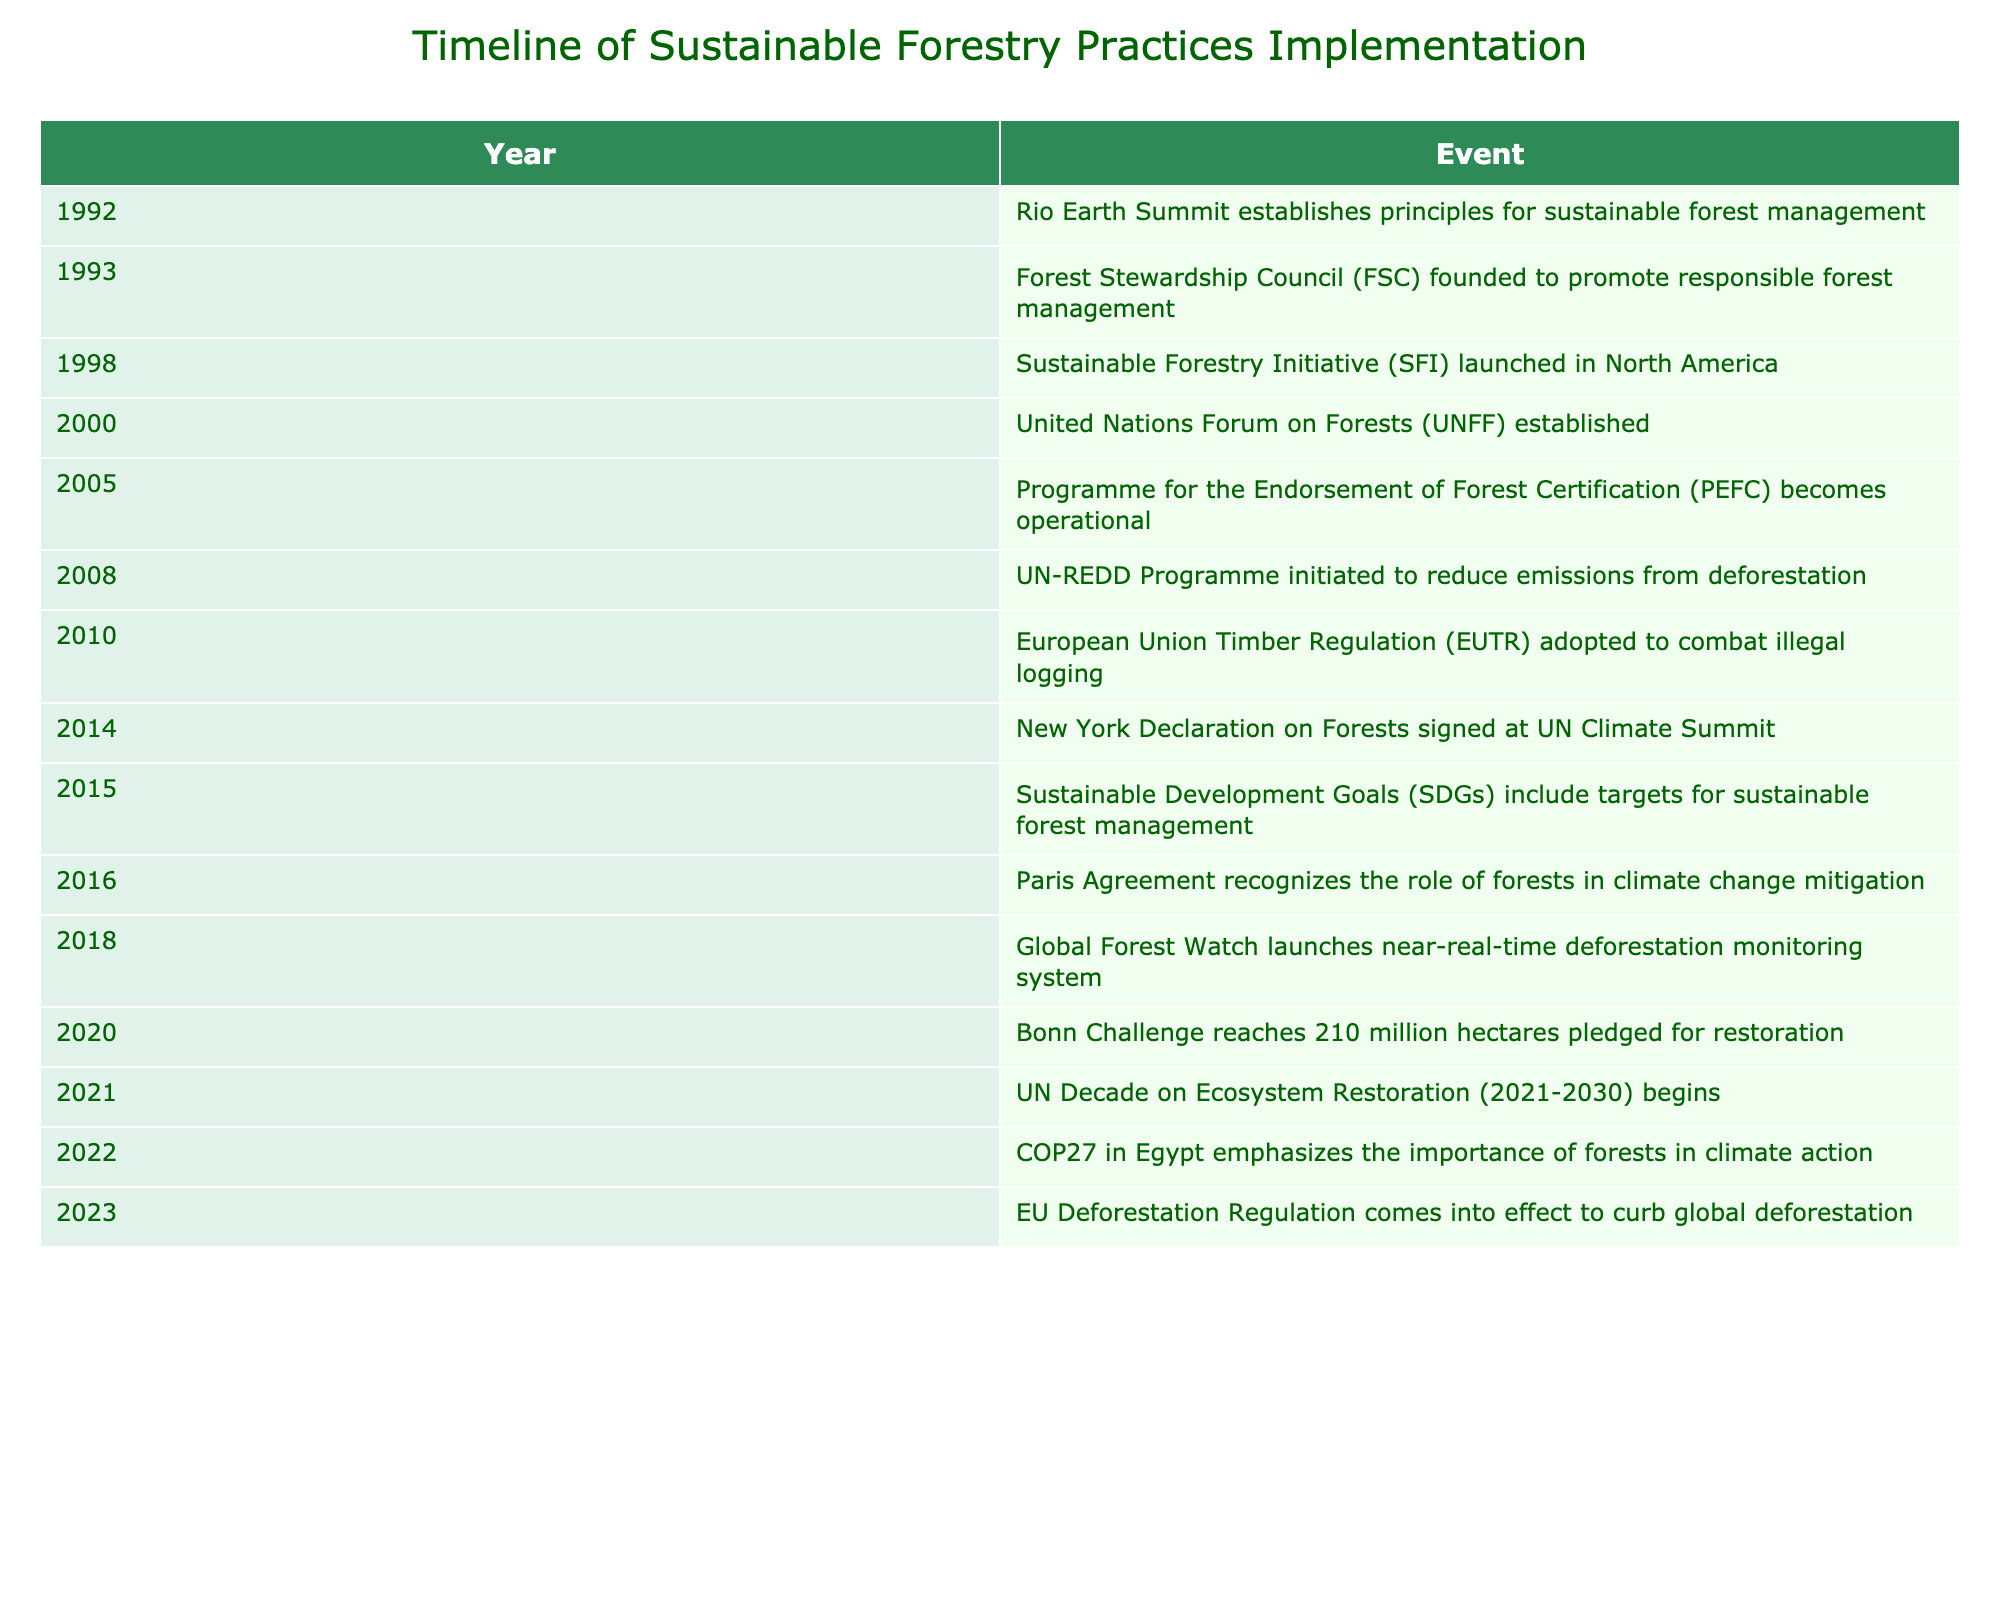What year did the Forest Stewardship Council (FSC) get founded? The table lists the events chronologically by year. Searching for "Forest Stewardship Council" in the events, I find that it was founded in 1993.
Answer: 1993 What event happened in 2016 related to climate change? By checking the year 2016 in the table, it indicates that the Paris Agreement recognizes the role of forests in climate change mitigation in that year.
Answer: Paris Agreement recognizes forests' role in climate change mitigation How many years passed between the establishment of the FSC and the launch of the Sustainable Forestry Initiative (SFI)? The FSC was founded in 1993 and the SFI was launched in 1998. The difference between these years is 1998 - 1993 = 5 years.
Answer: 5 years Was the European Union Timber Regulation adopted before the United Nations Forum on Forests was established? The table shows that the UNFF was established in the year 2000 and the EUTR was adopted in 2010. Comparing these dates, it is clear that the EUTR was adopted after the UNFF was established.
Answer: No What significant milestone in sustainable forestry occurred in 2020? Looking at the year 2020, the table states that the Bonn Challenge reached 210 million hectares pledged for restoration.
Answer: Bonn Challenge reached 210 million hectares pledged for restoration How many years were there between the signing of the New York Declaration on Forests and the establishment of the UN Decade on Ecosystem Restoration? The New York Declaration on Forests was signed in 2014 and the UN Decade on Ecosystem Restoration started in 2021. The difference in years is 2021 - 2014 = 7 years.
Answer: 7 years Did the UN-REDD Programme come into existence after the Sustainable Forestry Initiative (SFI) was launched? The SFI was launched in 1998 and the UN-REDD Programme was initiated in 2008. Comparing these years shows that the UN-REDD Programme indeed came into existence after the SFI.
Answer: Yes What is the only event listed for 2023 in the timeline? According to the table, the event in 2023 is the EU Deforestation Regulation coming into effect to curb global deforestation.
Answer: EU Deforestation Regulation comes into effect to curb global deforestation What are the two key initiatives launched in the years 2005 and 2008, and what are their focuses? In 2005, the Programme for the Endorsement of Forest Certification (PEFC) became operational, focused on forest certification. In 2008, the UN-REDD Programme initiated to reduce emissions from deforestation. These details can be cross-referenced with the years listed in the table.
Answer: PEFC (2005) - forest certification; UN-REDD (2008) - reduce emissions from deforestation In which year did the Sustainable Development Goals (SDGs) include targets for sustainable forest management? The table indicates that the SDGs included targets for sustainable forest management in 2015.
Answer: 2015 